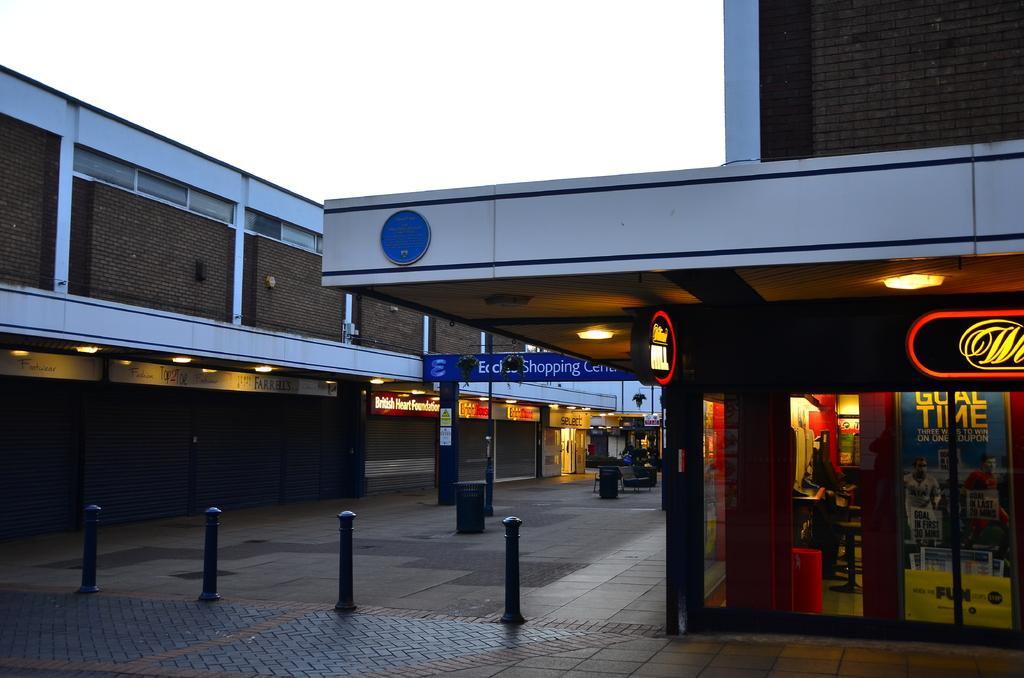Is there a shopping center in the photo?
Keep it short and to the point. Yes. 